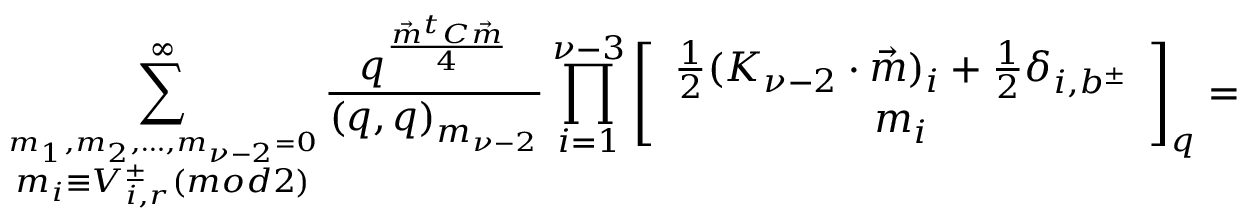Convert formula to latex. <formula><loc_0><loc_0><loc_500><loc_500>\sum _ { \stackrel { m _ { 1 } , m _ { 2 } , \dots , m _ { \nu - 2 } = 0 } { m _ { i } \equiv V _ { i , r } ^ { \pm } ( m o d 2 ) } } ^ { \infty } \frac { q ^ { \frac { \vec { m } ^ { t } C \vec { m } } { 4 } } } { ( q , q ) _ { m _ { \nu - 2 } } } \prod _ { i = 1 } ^ { \nu - 3 } \left [ \begin{array} { c } { { \frac { 1 } { 2 } ( K _ { \nu - 2 } \cdot \vec { m } ) _ { i } + \frac { 1 } { 2 } \delta _ { i , b ^ { \pm } } } } \\ { { m _ { i } } } \end{array} \right ] _ { q } =</formula> 